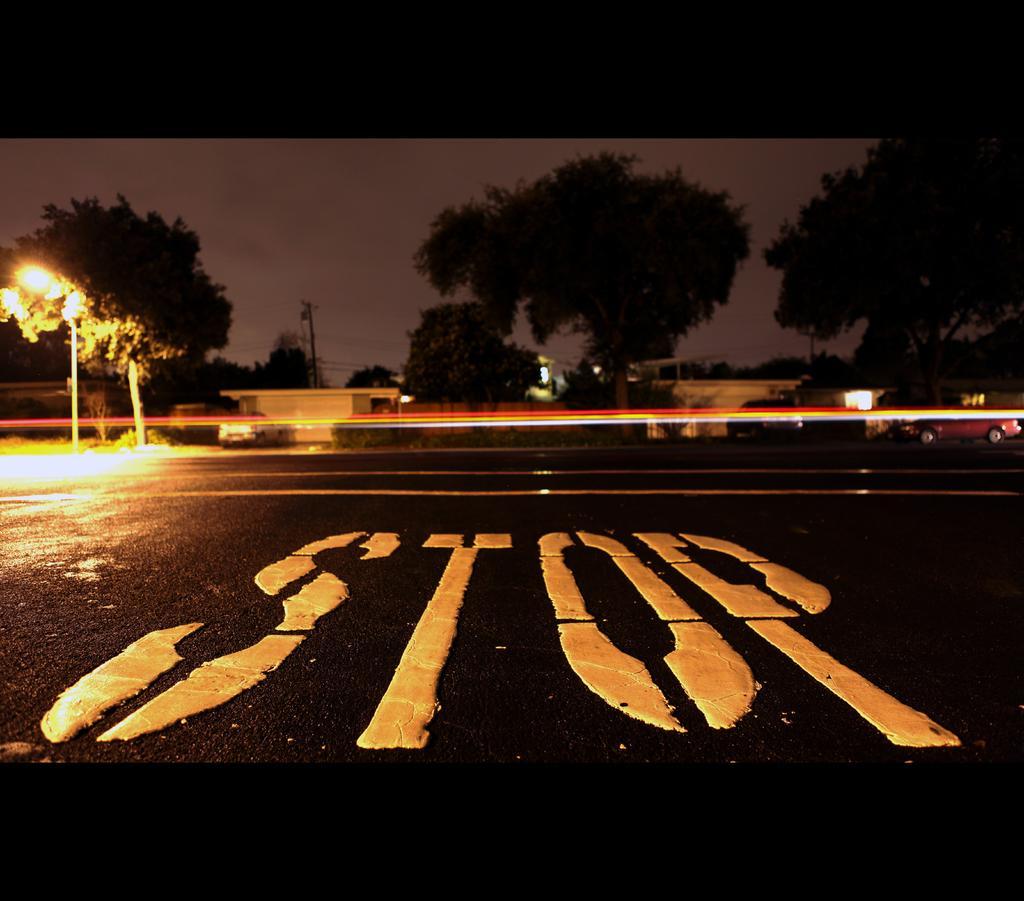Please provide a concise description of this image. This is the picture of a road. In this image there are trees, buildings and poles. There is a vehicle on the road. At the top there is sky. At the bottom there is a road and there is a text on the road. 